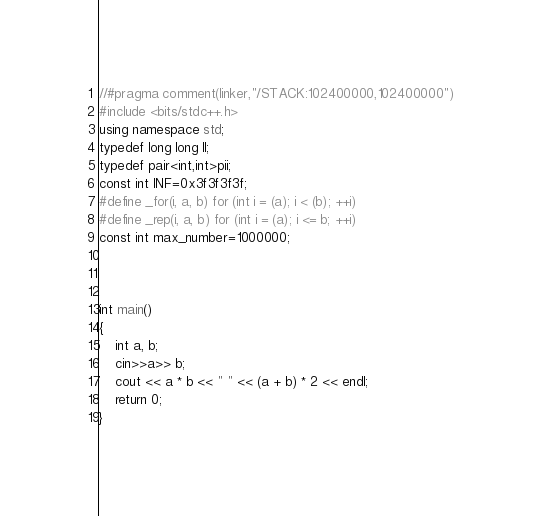Convert code to text. <code><loc_0><loc_0><loc_500><loc_500><_C++_>//#pragma comment(linker,"/STACK:102400000,102400000")
#include <bits/stdc++.h>
using namespace std;
typedef long long ll;
typedef pair<int,int>pii;
const int INF=0x3f3f3f3f;
#define _for(i, a, b) for (int i = (a); i < (b); ++i)
#define _rep(i, a, b) for (int i = (a); i <= b; ++i)
const int max_number=1000000;



int main()
{
    int a, b;
    cin>>a>> b;
    cout << a * b << " " << (a + b) * 2 << endl;
    return 0;
}
</code> 